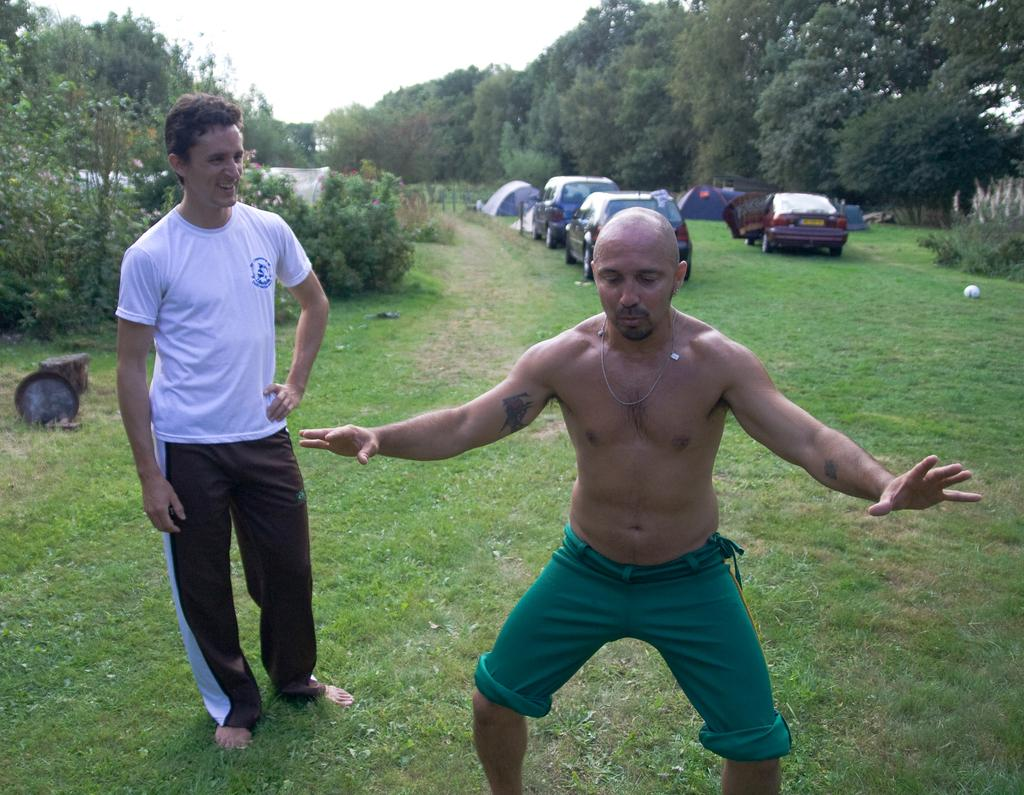What are the men in the image doing? The men in the image are standing on the ground. What else can be seen on the ground in the image? Motor vehicles are present on the ground in the image. What type of vegetation is visible in the image? Bushes and trees are present in the image. What is visible above the ground in the image? The sky is visible in the image. What type of gun is being used by the men in the image? There is no gun present in the image; the men are simply standing on the ground. 